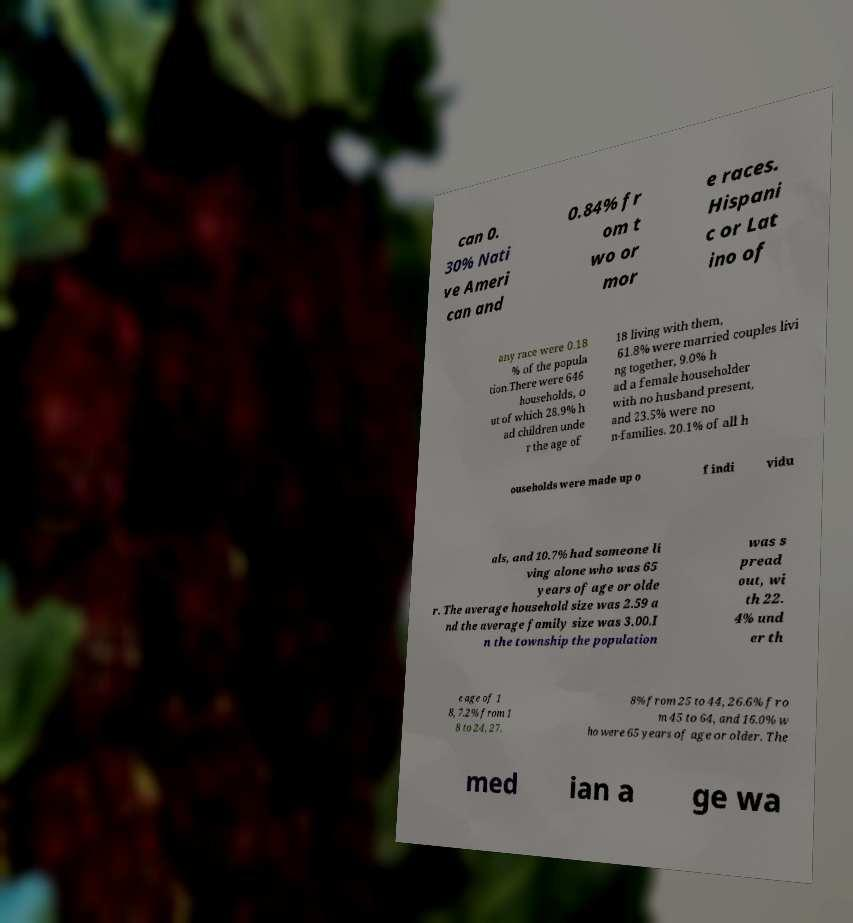Please read and relay the text visible in this image. What does it say? can 0. 30% Nati ve Ameri can and 0.84% fr om t wo or mor e races. Hispani c or Lat ino of any race were 0.18 % of the popula tion.There were 646 households, o ut of which 28.9% h ad children unde r the age of 18 living with them, 61.8% were married couples livi ng together, 9.0% h ad a female householder with no husband present, and 23.5% were no n-families. 20.1% of all h ouseholds were made up o f indi vidu als, and 10.7% had someone li ving alone who was 65 years of age or olde r. The average household size was 2.59 a nd the average family size was 3.00.I n the township the population was s pread out, wi th 22. 4% und er th e age of 1 8, 7.2% from 1 8 to 24, 27. 8% from 25 to 44, 26.6% fro m 45 to 64, and 16.0% w ho were 65 years of age or older. The med ian a ge wa 